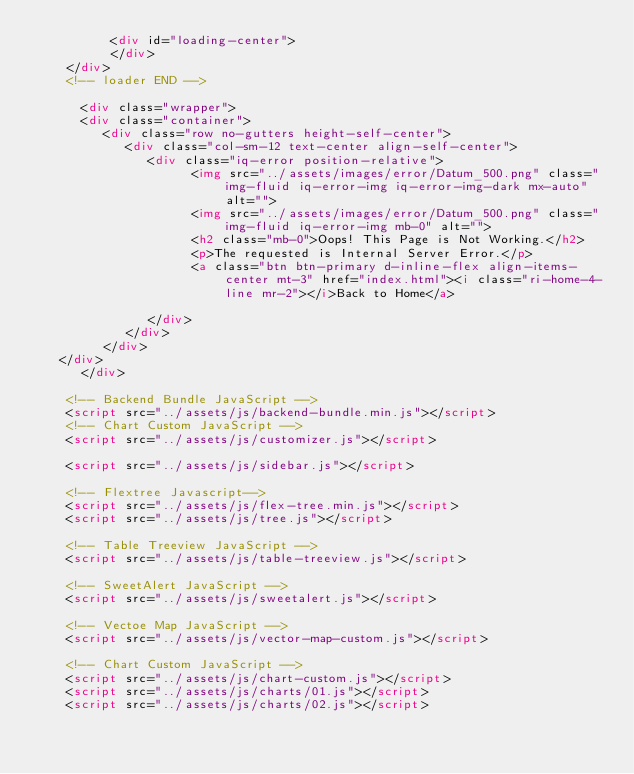<code> <loc_0><loc_0><loc_500><loc_500><_HTML_>          <div id="loading-center">
          </div>
    </div>
    <!-- loader END -->
    
      <div class="wrapper">
      <div class="container">
         <div class="row no-gutters height-self-center">
            <div class="col-sm-12 text-center align-self-center">
               <div class="iq-error position-relative">
                     <img src="../assets/images/error/Datum_500.png" class="img-fluid iq-error-img iq-error-img-dark mx-auto" alt="">
                     <img src="../assets/images/error/Datum_500.png" class="img-fluid iq-error-img mb-0" alt="">
                     <h2 class="mb-0">Oops! This Page is Not Working.</h2>
                     <p>The requested is Internal Server Error.</p>
                     <a class="btn btn-primary d-inline-flex align-items-center mt-3" href="index.html"><i class="ri-home-4-line mr-2"></i>Back to Home</a>
                     
               </div>
            </div>
         </div>
   </div>
      </div>
    
    <!-- Backend Bundle JavaScript -->
    <script src="../assets/js/backend-bundle.min.js"></script>
    <!-- Chart Custom JavaScript -->
    <script src="../assets/js/customizer.js"></script>
    
    <script src="../assets/js/sidebar.js"></script>
    
    <!-- Flextree Javascript-->
    <script src="../assets/js/flex-tree.min.js"></script>
    <script src="../assets/js/tree.js"></script>
    
    <!-- Table Treeview JavaScript -->
    <script src="../assets/js/table-treeview.js"></script>
    
    <!-- SweetAlert JavaScript -->
    <script src="../assets/js/sweetalert.js"></script>
    
    <!-- Vectoe Map JavaScript -->
    <script src="../assets/js/vector-map-custom.js"></script>
    
    <!-- Chart Custom JavaScript -->
    <script src="../assets/js/chart-custom.js"></script>
    <script src="../assets/js/charts/01.js"></script>
    <script src="../assets/js/charts/02.js"></script></code> 